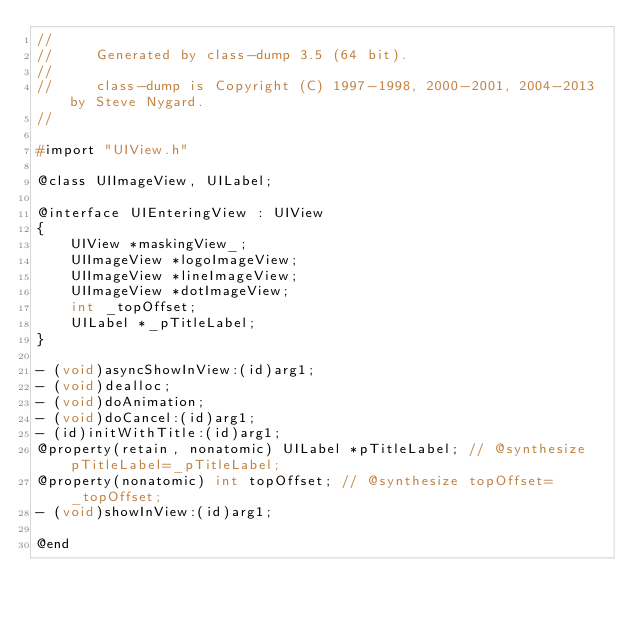<code> <loc_0><loc_0><loc_500><loc_500><_C_>//
//     Generated by class-dump 3.5 (64 bit).
//
//     class-dump is Copyright (C) 1997-1998, 2000-2001, 2004-2013 by Steve Nygard.
//

#import "UIView.h"

@class UIImageView, UILabel;

@interface UIEnteringView : UIView
{
    UIView *maskingView_;
    UIImageView *logoImageView;
    UIImageView *lineImageView;
    UIImageView *dotImageView;
    int _topOffset;
    UILabel *_pTitleLabel;
}

- (void)asyncShowInView:(id)arg1;
- (void)dealloc;
- (void)doAnimation;
- (void)doCancel:(id)arg1;
- (id)initWithTitle:(id)arg1;
@property(retain, nonatomic) UILabel *pTitleLabel; // @synthesize pTitleLabel=_pTitleLabel;
@property(nonatomic) int topOffset; // @synthesize topOffset=_topOffset;
- (void)showInView:(id)arg1;

@end

</code> 